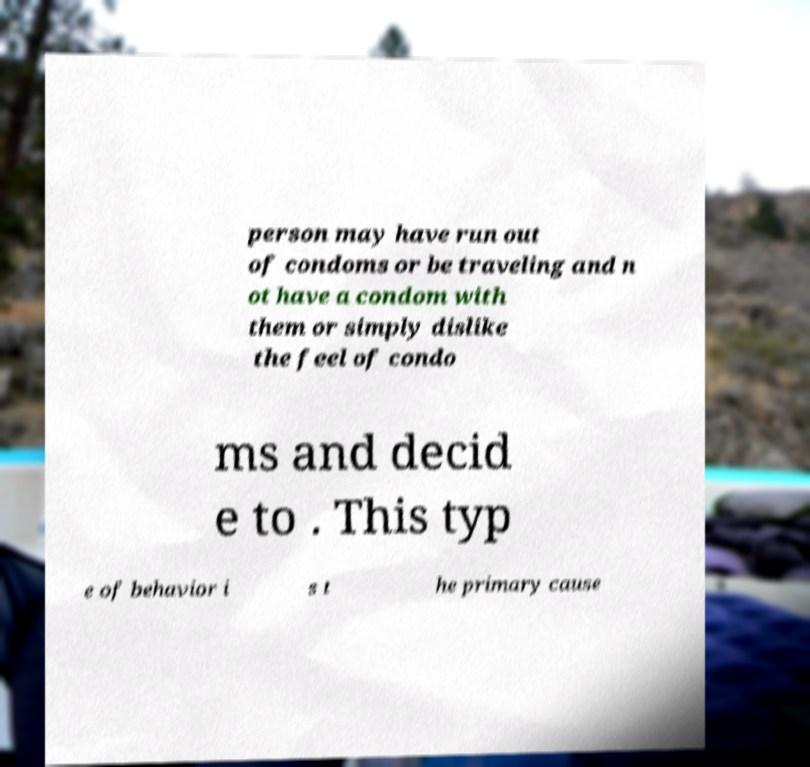Could you assist in decoding the text presented in this image and type it out clearly? person may have run out of condoms or be traveling and n ot have a condom with them or simply dislike the feel of condo ms and decid e to . This typ e of behavior i s t he primary cause 